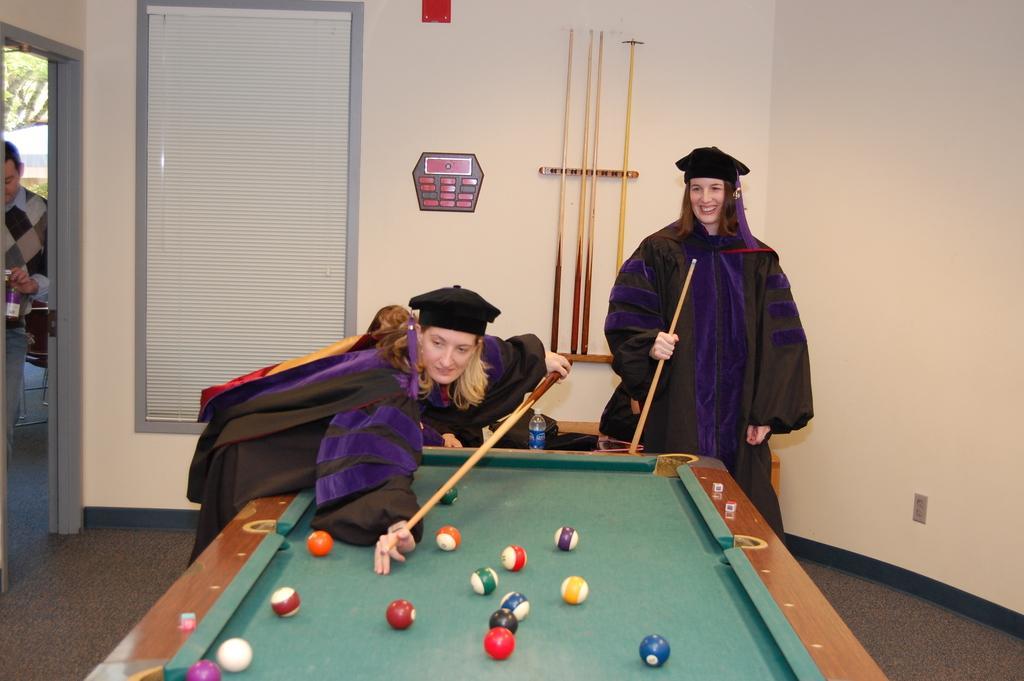Could you give a brief overview of what you see in this image? On the background we can see wall, snookers stick on a wall. Here we can see a man standing near to the door and holding a bottle in his hand. This is a door. Here we can see two women standing and playing snooker game. 